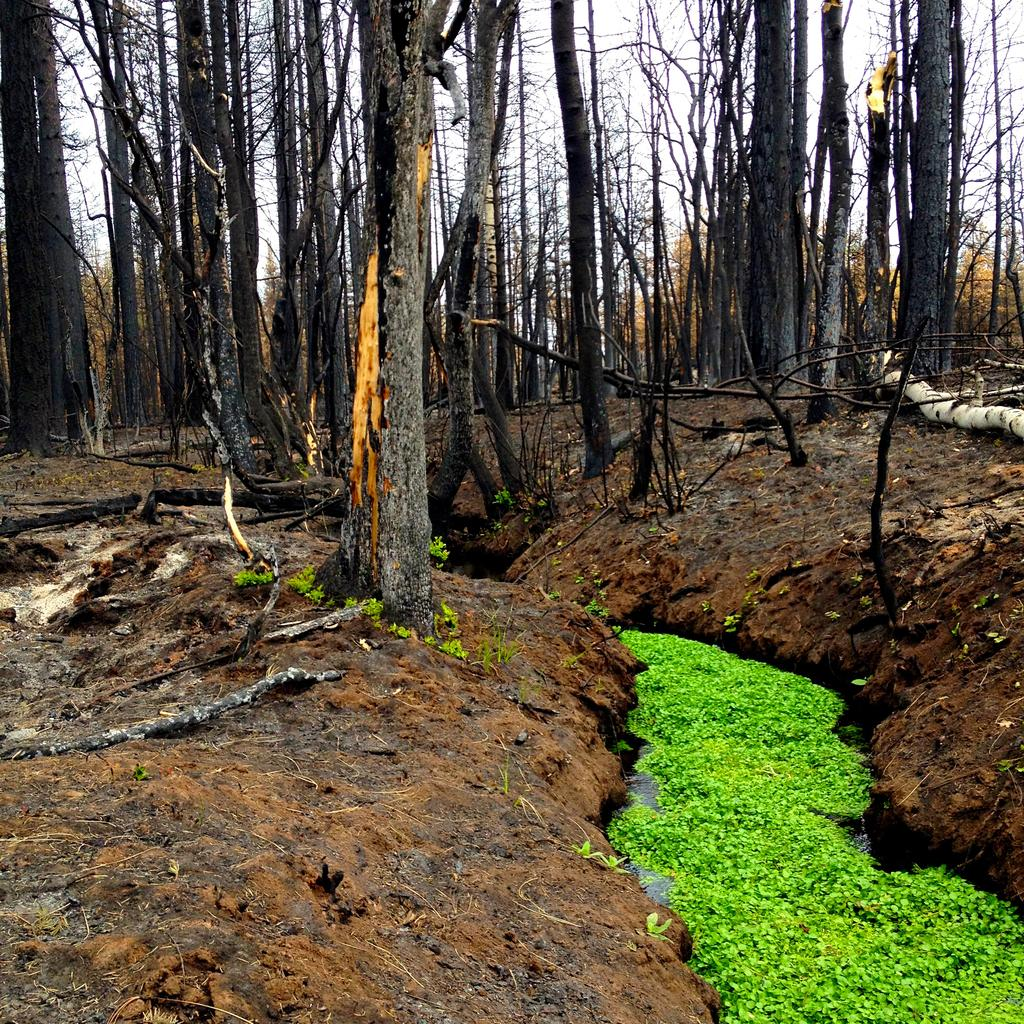What type of vegetation can be seen in the image? There are trees in the image. What is the condition of the trees? The trees are completely dried. What can be seen in the background of the image? There is sky visible in the background of the image. Where is the goat in the image? There is no goat present in the image. What is the goat using to collect water in the image? There is no goat or bucket present in the image. 